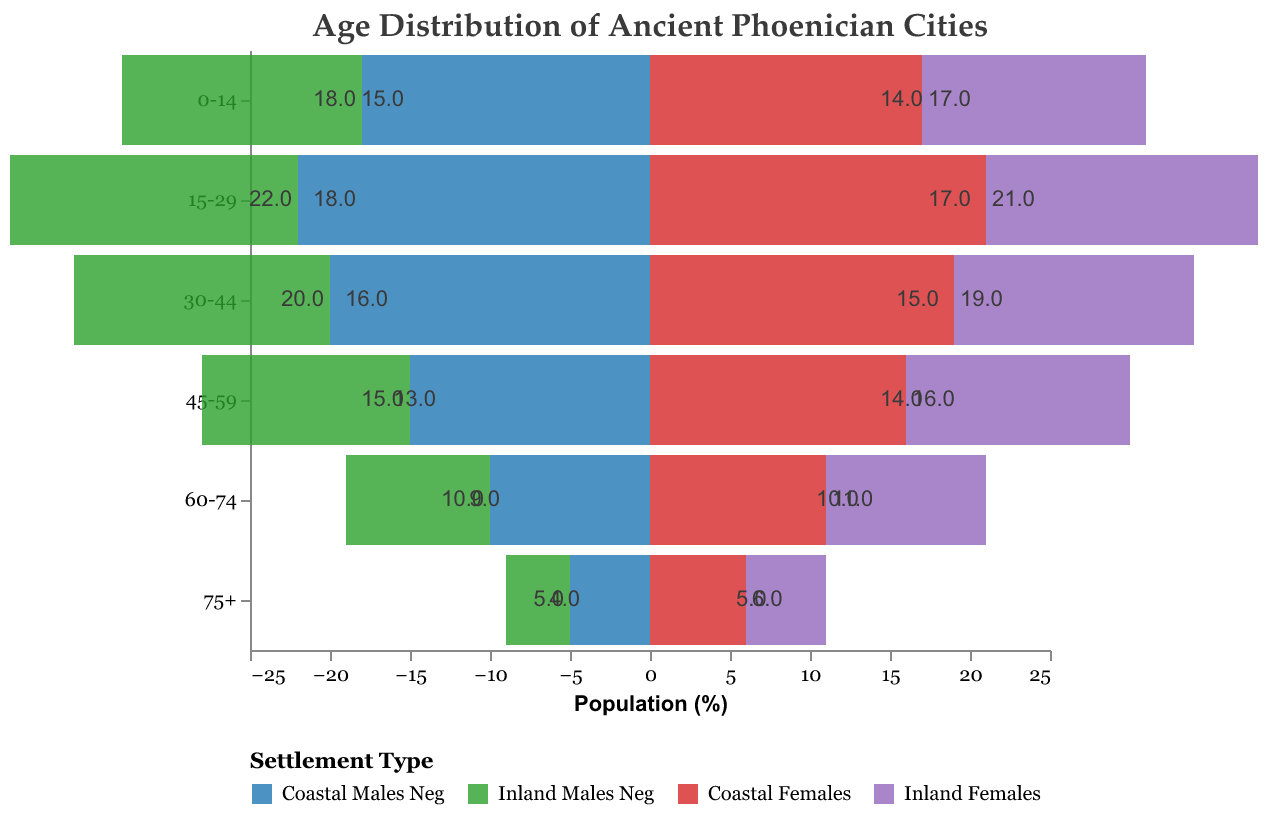What's the title of the figure? The title of the figure is typically displayed at the top and provides an overview of what the figure represents.
Answer: Age Distribution of Ancient Phoenician Cities How many age groups are represented in the figure? The age groups are represented on the y-axis. Counting the labels from top to bottom gives the total number of age groups.
Answer: 6 Which age group has the highest population for Coastal Males? By comparing the lengths of the bars representing Coastal Males for each age group, the age group with the longest bar is identified as having the highest population.
Answer: 15-29 What is the population percentage of Inland Females in the 60-74 age group? The bar for Inland Females in the 60-74 age group ends at 10 in the positive direction, indicating their population percentage.
Answer: 10% Compare the population percentages of Coastal Females and Inland Females in the 0-14 age group. To compare, look at the bars for both Coastal Females and Inland Females in the 0-14 age group. Coastal Females is at 17, and Inland Females is at 14.
Answer: Coastal Females: 17%, Inland Females: 14% Which age group shows the most significant difference in population between Coastal Males and Inland Males? By calculating the differences between Coastal Males and Inland Males for each age group and comparing them, the largest difference is found.
Answer: 15-29 What is the total population percentage of Coastal Males and Coastal Females in the age group 30-44? Adding the population percentages of Coastal Males and Coastal Females in the 30-44 age group, which are 20% and 19% respectively, gives the total.
Answer: 39% In the 75+ age group, which gender and settlement type has the lowest population percentage? By comparing the bars in the 75+ age group, the shortest bar is identified as representing the lowest population percentage.
Answer: Inland Males Compare the gender distribution in the 45-59 age group for Coastal settlements. In the coastal 45-59 age group, compare the heights of the bars representing males and females. Coastal Males are at 15%, and Coastal Females are at 16%.
Answer: Coastal Males: 15%, Coastal Females: 16% Is the population of Coastal Females in the 15-29 age group higher or lower than the population of Inland Males in the same age group? By comparing the lengths of the bars for Coastal Females (21%) and Inland Males (18%) in the 15-29 age group, the higher one is identified.
Answer: Higher 